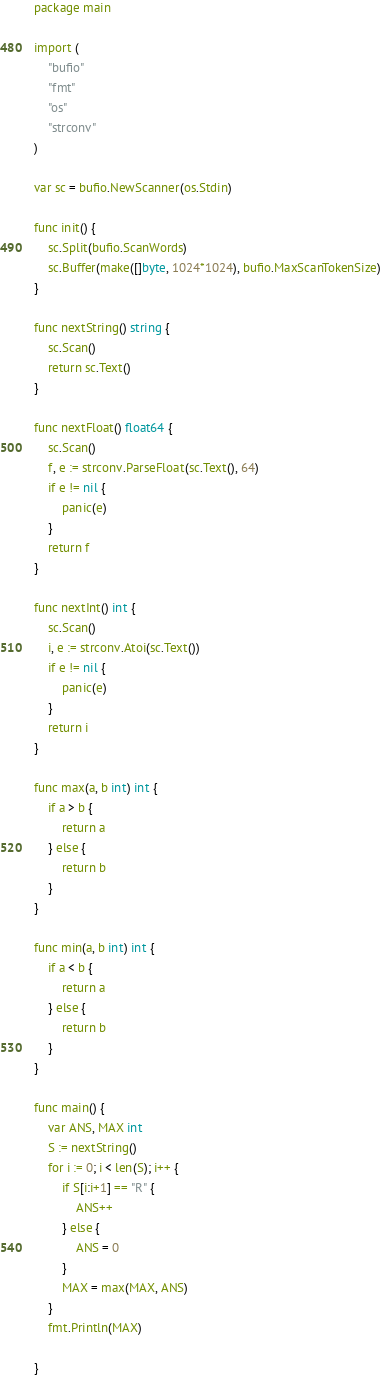Convert code to text. <code><loc_0><loc_0><loc_500><loc_500><_Go_>package main

import (
	"bufio"
	"fmt"
	"os"
	"strconv"
)

var sc = bufio.NewScanner(os.Stdin)

func init() {
	sc.Split(bufio.ScanWords)
	sc.Buffer(make([]byte, 1024*1024), bufio.MaxScanTokenSize)
}

func nextString() string {
	sc.Scan()
	return sc.Text()
}

func nextFloat() float64 {
	sc.Scan()
	f, e := strconv.ParseFloat(sc.Text(), 64)
	if e != nil {
		panic(e)
	}
	return f
}

func nextInt() int {
	sc.Scan()
	i, e := strconv.Atoi(sc.Text())
	if e != nil {
		panic(e)
	}
	return i
}

func max(a, b int) int {
	if a > b {
		return a
	} else {
		return b
	}
}

func min(a, b int) int {
	if a < b {
		return a
	} else {
		return b
	}
}

func main() {
	var ANS, MAX int
	S := nextString()
	for i := 0; i < len(S); i++ {
		if S[i:i+1] == "R" {
			ANS++
		} else {
			ANS = 0
		}
		MAX = max(MAX, ANS)
	}
	fmt.Println(MAX)

}
</code> 